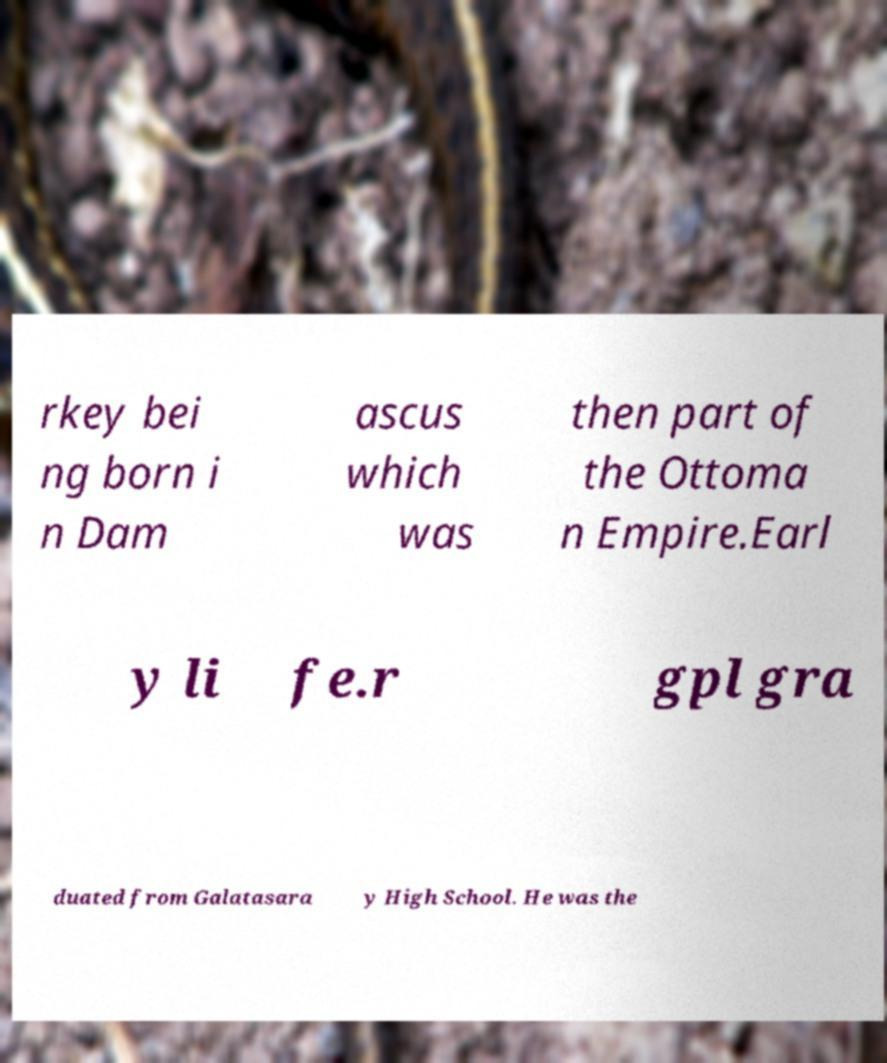Can you accurately transcribe the text from the provided image for me? rkey bei ng born i n Dam ascus which was then part of the Ottoma n Empire.Earl y li fe.r gpl gra duated from Galatasara y High School. He was the 